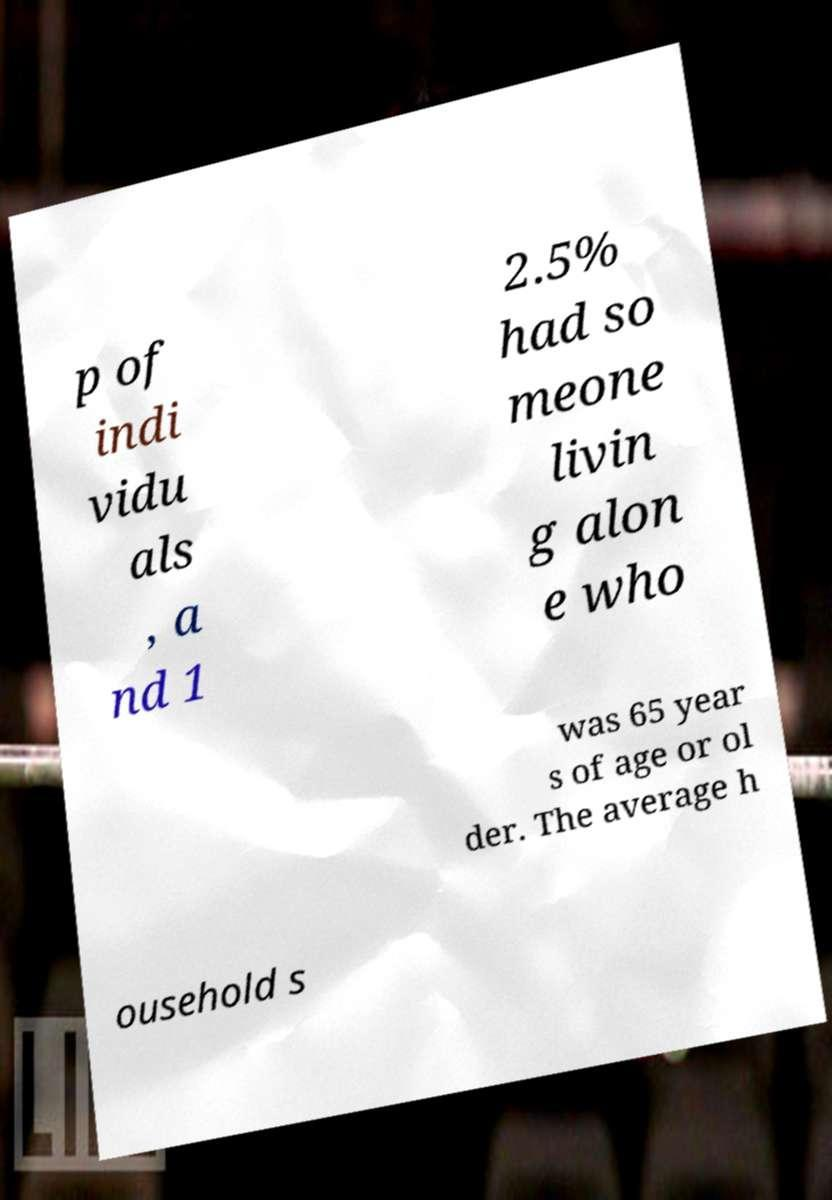Please identify and transcribe the text found in this image. p of indi vidu als , a nd 1 2.5% had so meone livin g alon e who was 65 year s of age or ol der. The average h ousehold s 